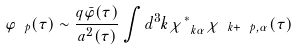Convert formula to latex. <formula><loc_0><loc_0><loc_500><loc_500>\varphi _ { \ p } ( \tau ) \sim \frac { q { \bar { \varphi } } ( \tau ) } { a ^ { 2 } ( \tau ) } \int d ^ { 3 } k \chi _ { \ k \alpha } ^ { * } \chi _ { \ k + \ p , \alpha } ( \tau )</formula> 